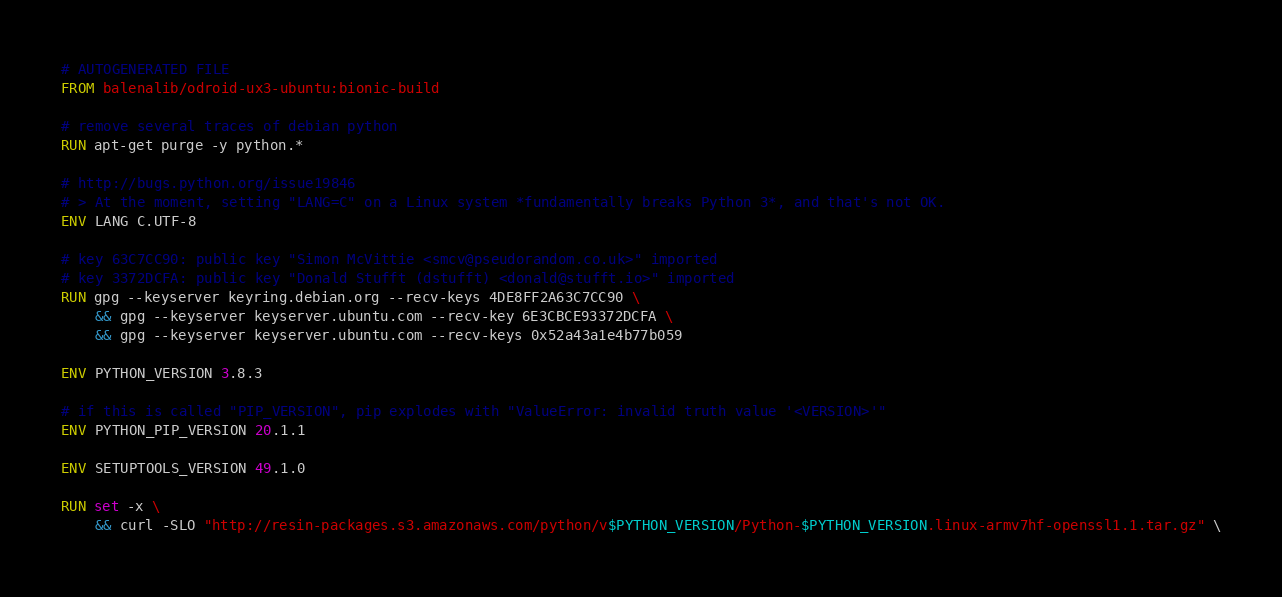Convert code to text. <code><loc_0><loc_0><loc_500><loc_500><_Dockerfile_># AUTOGENERATED FILE
FROM balenalib/odroid-ux3-ubuntu:bionic-build

# remove several traces of debian python
RUN apt-get purge -y python.*

# http://bugs.python.org/issue19846
# > At the moment, setting "LANG=C" on a Linux system *fundamentally breaks Python 3*, and that's not OK.
ENV LANG C.UTF-8

# key 63C7CC90: public key "Simon McVittie <smcv@pseudorandom.co.uk>" imported
# key 3372DCFA: public key "Donald Stufft (dstufft) <donald@stufft.io>" imported
RUN gpg --keyserver keyring.debian.org --recv-keys 4DE8FF2A63C7CC90 \
	&& gpg --keyserver keyserver.ubuntu.com --recv-key 6E3CBCE93372DCFA \
	&& gpg --keyserver keyserver.ubuntu.com --recv-keys 0x52a43a1e4b77b059

ENV PYTHON_VERSION 3.8.3

# if this is called "PIP_VERSION", pip explodes with "ValueError: invalid truth value '<VERSION>'"
ENV PYTHON_PIP_VERSION 20.1.1

ENV SETUPTOOLS_VERSION 49.1.0

RUN set -x \
	&& curl -SLO "http://resin-packages.s3.amazonaws.com/python/v$PYTHON_VERSION/Python-$PYTHON_VERSION.linux-armv7hf-openssl1.1.tar.gz" \</code> 